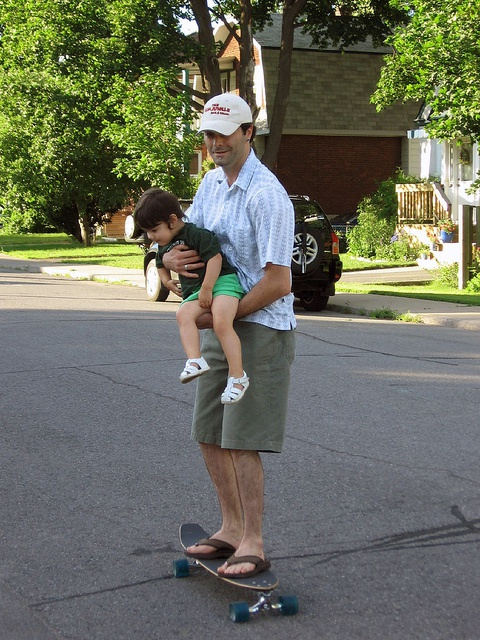Describe the objects in this image and their specific colors. I can see people in olive, gray, lavender, and black tones, people in olive, black, gray, tan, and darkgray tones, car in olive, black, gray, darkgray, and darkgreen tones, and skateboard in olive, black, gray, and darkblue tones in this image. 